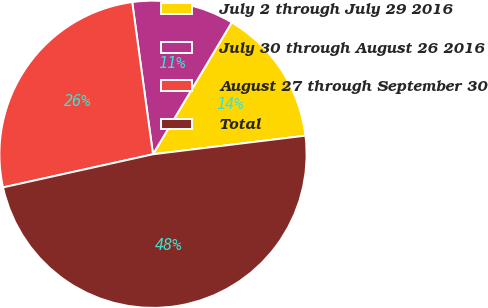Convert chart. <chart><loc_0><loc_0><loc_500><loc_500><pie_chart><fcel>July 2 through July 29 2016<fcel>July 30 through August 26 2016<fcel>August 27 through September 30<fcel>Total<nl><fcel>14.5%<fcel>10.73%<fcel>26.3%<fcel>48.47%<nl></chart> 